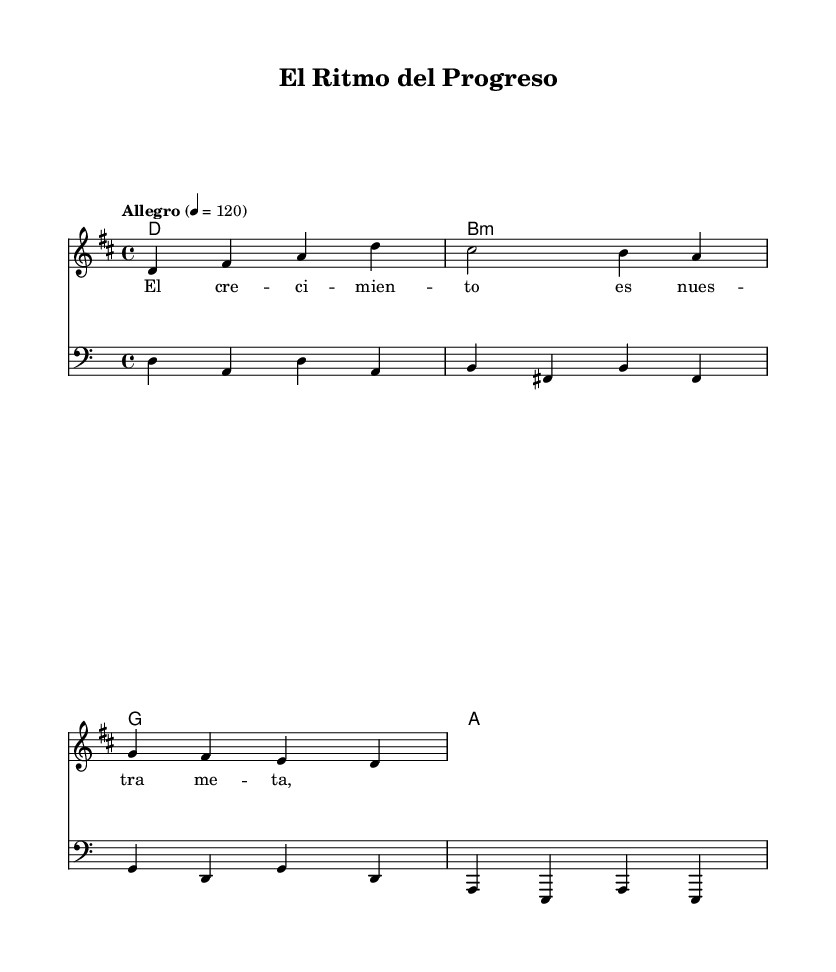What is the key signature of this music? The key signature is D major, indicated by the presence of two sharps (F# and C#).
Answer: D major What is the time signature of the piece? The time signature is 4/4, which is commonly notated with a "4" over a "4" at the beginning of the score.
Answer: 4/4 What is the tempo marking given? The tempo marking provided in the score is "Allegro," which indicates a fast tempo, usually around 120 beats per minute.
Answer: Allegro How many measures are in the melody? The melody contains four measures, each separated by vertical lines in the score. Counting these gives a total of four.
Answer: Four What are the starting notes of the melody? The starting notes of the melody, as shown in the sheet music, are D and F#, which are the first two notes played.
Answer: D, F# What type of harmonies are used in the chord progression? The chord progression includes major and minor chords, specifically D major, B minor, G major, and A major chords.
Answer: Major and minor chords What lyric corresponds to the first melody note? The lyric that corresponds to the first note (D) in the melody is "El," which is the first word of the given lyrics.
Answer: El 